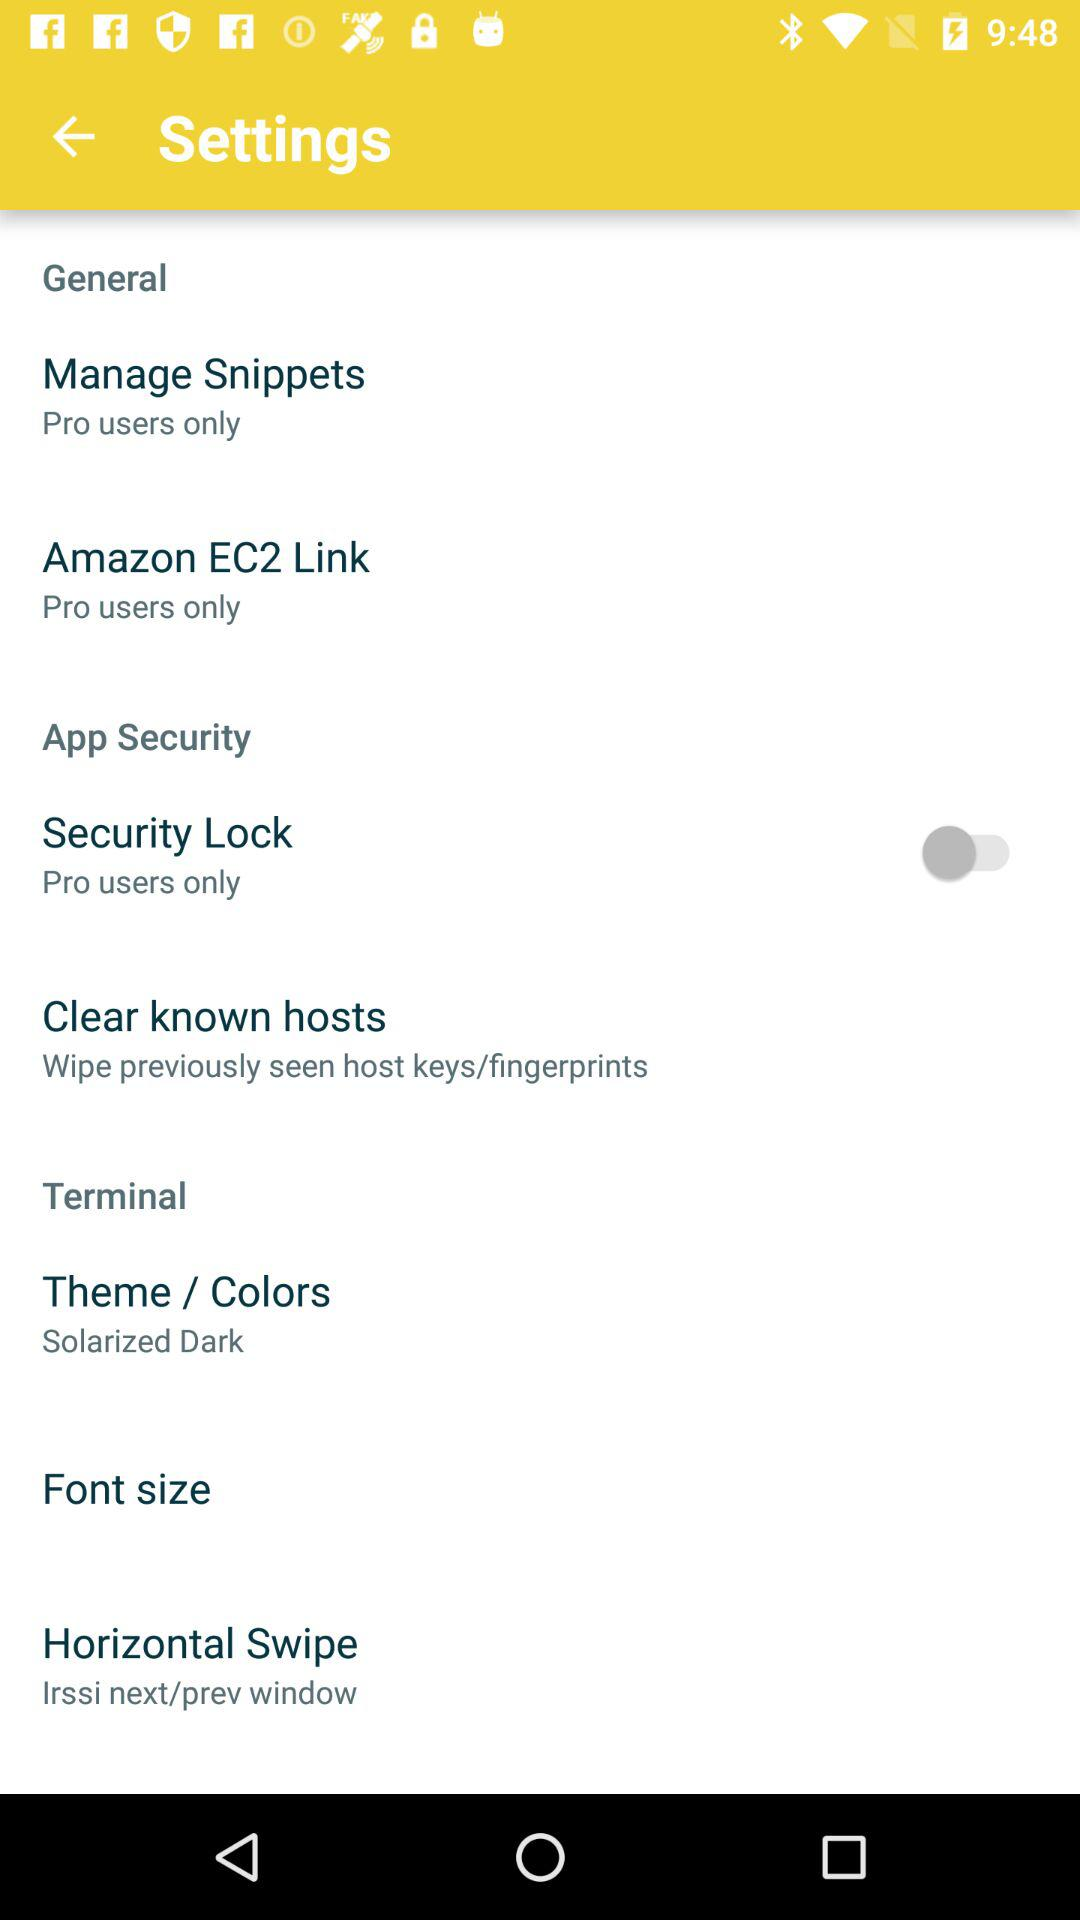Manage snippets is only for which type of user? Manage snippets is only for pro users. 